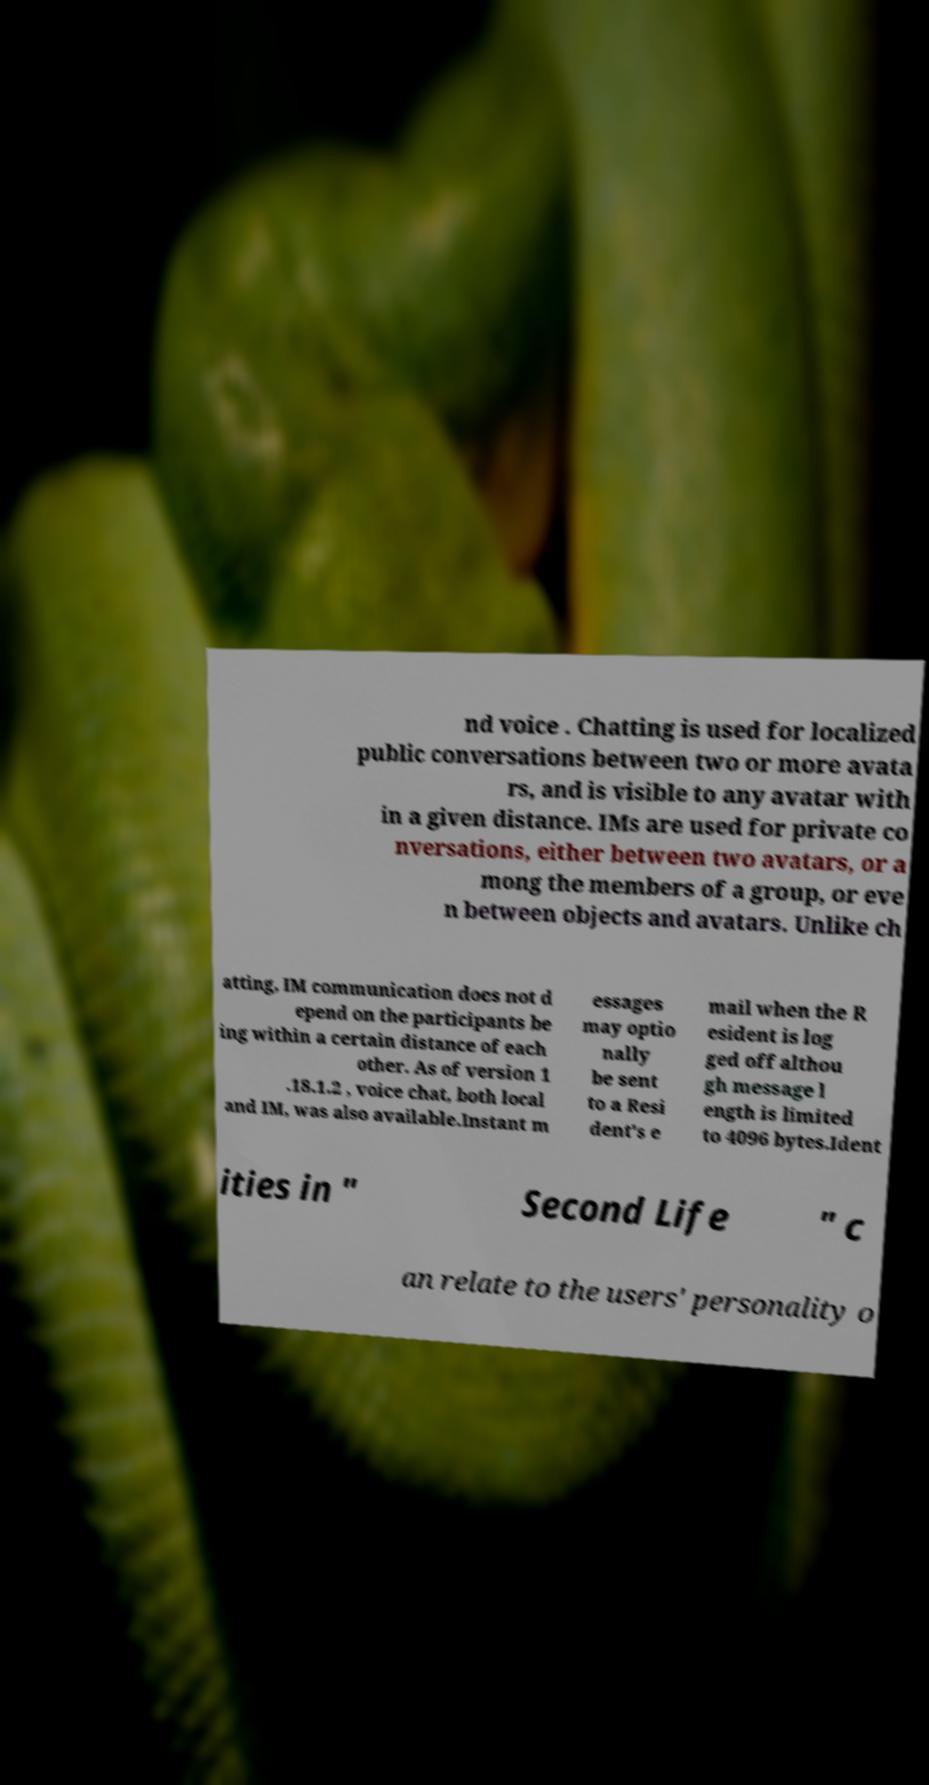I need the written content from this picture converted into text. Can you do that? nd voice . Chatting is used for localized public conversations between two or more avata rs, and is visible to any avatar with in a given distance. IMs are used for private co nversations, either between two avatars, or a mong the members of a group, or eve n between objects and avatars. Unlike ch atting, IM communication does not d epend on the participants be ing within a certain distance of each other. As of version 1 .18.1.2 , voice chat, both local and IM, was also available.Instant m essages may optio nally be sent to a Resi dent's e mail when the R esident is log ged off althou gh message l ength is limited to 4096 bytes.Ident ities in " Second Life " c an relate to the users' personality o 